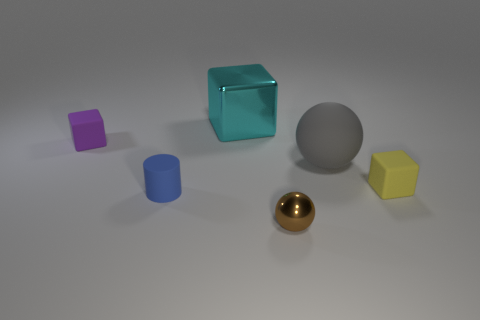There is a tiny thing that is both behind the blue rubber cylinder and in front of the gray sphere; what is it made of?
Ensure brevity in your answer.  Rubber. What color is the other matte thing that is the same size as the cyan thing?
Your answer should be very brief. Gray. Are the brown sphere and the block that is right of the gray ball made of the same material?
Provide a short and direct response. No. What number of other objects are there of the same size as the yellow cube?
Give a very brief answer. 3. There is a large rubber sphere that is in front of the shiny object behind the purple thing; is there a matte object that is on the right side of it?
Provide a short and direct response. Yes. The shiny ball has what size?
Give a very brief answer. Small. There is a sphere that is behind the small blue thing; how big is it?
Give a very brief answer. Large. There is a matte cube that is to the right of the purple rubber thing; does it have the same size as the cyan metallic thing?
Keep it short and to the point. No. Is there anything else that is the same color as the tiny metallic sphere?
Your response must be concise. No. The small brown metal object is what shape?
Your answer should be compact. Sphere. 